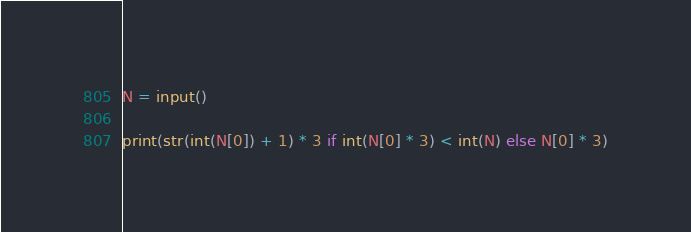Convert code to text. <code><loc_0><loc_0><loc_500><loc_500><_Python_>N = input()

print(str(int(N[0]) + 1) * 3 if int(N[0] * 3) < int(N) else N[0] * 3)</code> 